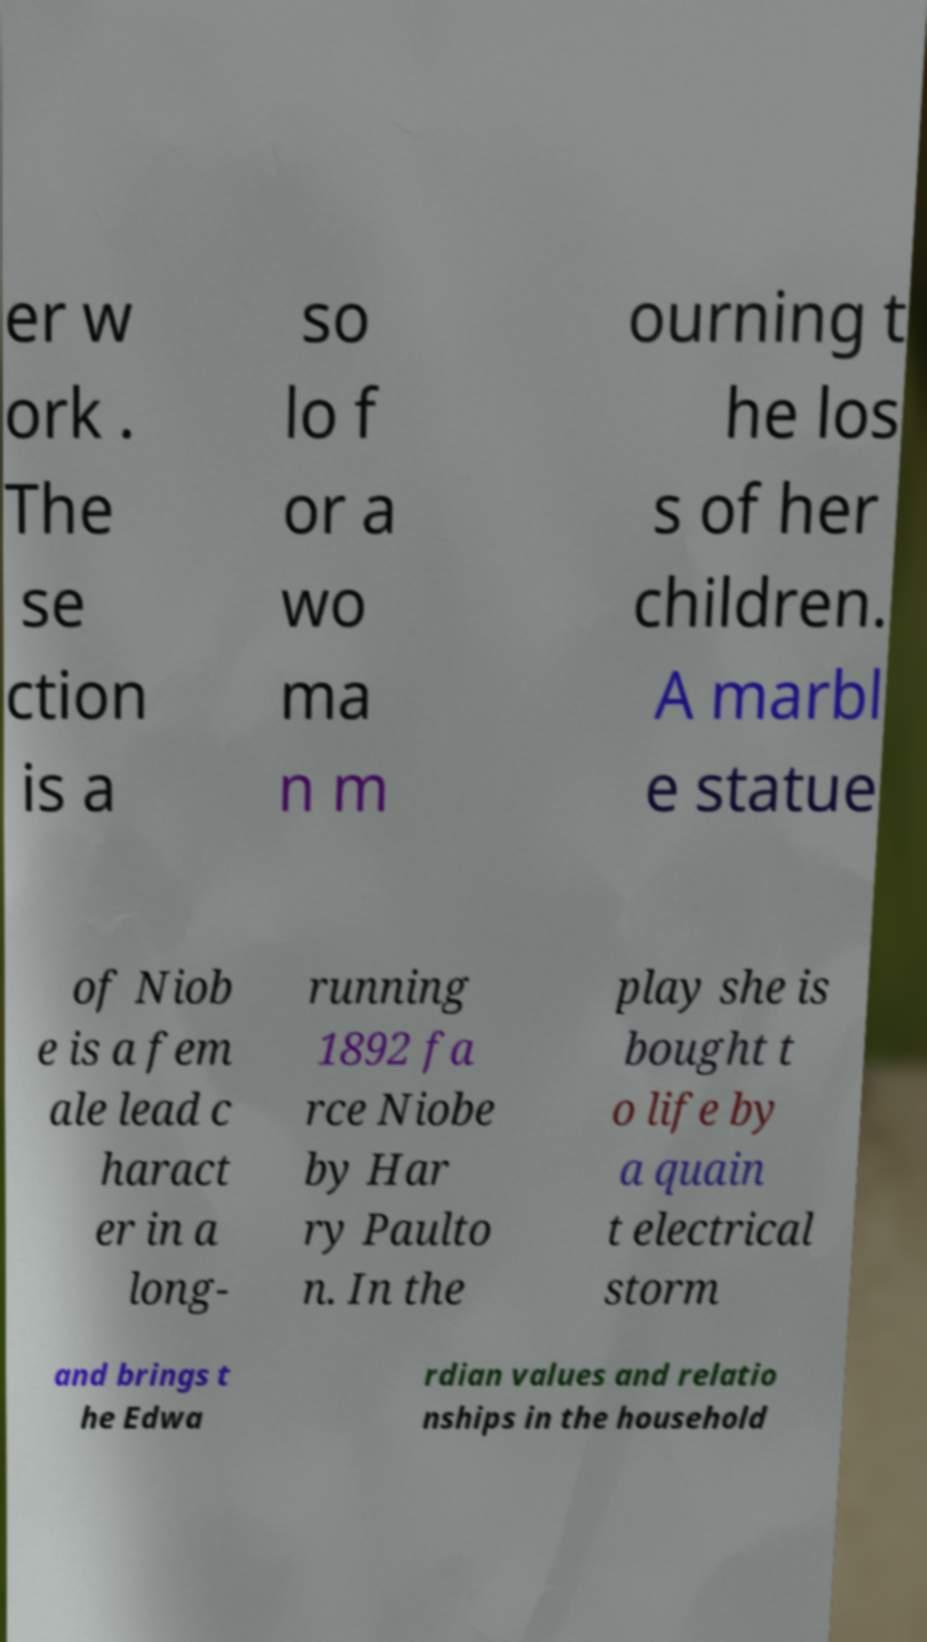Please read and relay the text visible in this image. What does it say? er w ork . The se ction is a so lo f or a wo ma n m ourning t he los s of her children. A marbl e statue of Niob e is a fem ale lead c haract er in a long- running 1892 fa rce Niobe by Har ry Paulto n. In the play she is bought t o life by a quain t electrical storm and brings t he Edwa rdian values and relatio nships in the household 